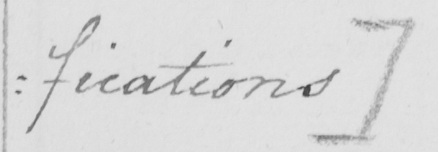Please transcribe the handwritten text in this image. : fications ] 